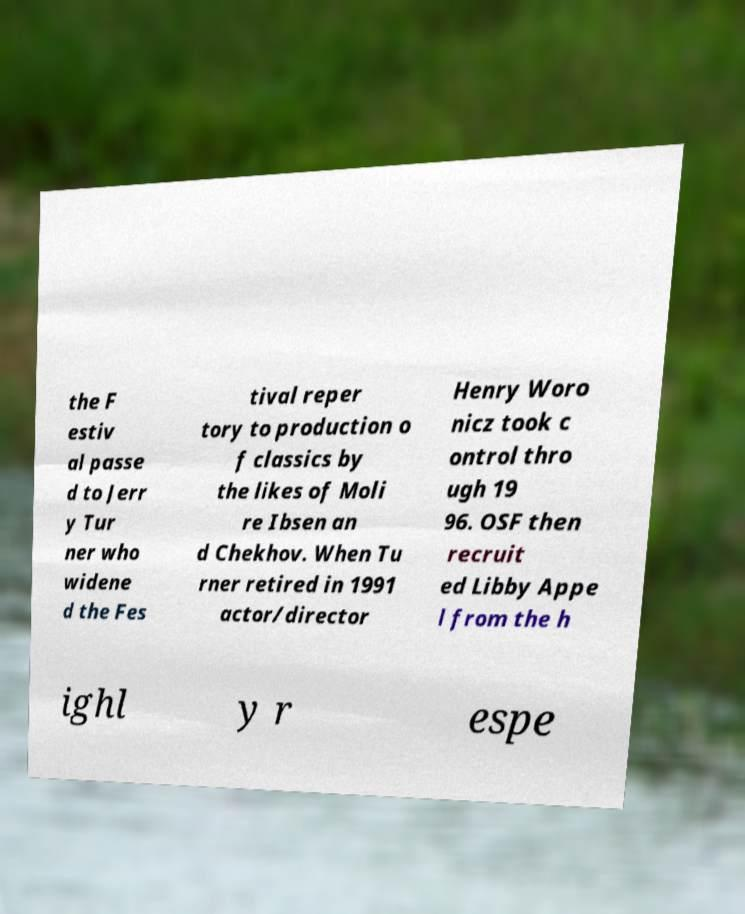What messages or text are displayed in this image? I need them in a readable, typed format. the F estiv al passe d to Jerr y Tur ner who widene d the Fes tival reper tory to production o f classics by the likes of Moli re Ibsen an d Chekhov. When Tu rner retired in 1991 actor/director Henry Woro nicz took c ontrol thro ugh 19 96. OSF then recruit ed Libby Appe l from the h ighl y r espe 